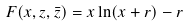<formula> <loc_0><loc_0><loc_500><loc_500>F ( x , z , \bar { z } ) = x \ln ( x + r ) - r</formula> 